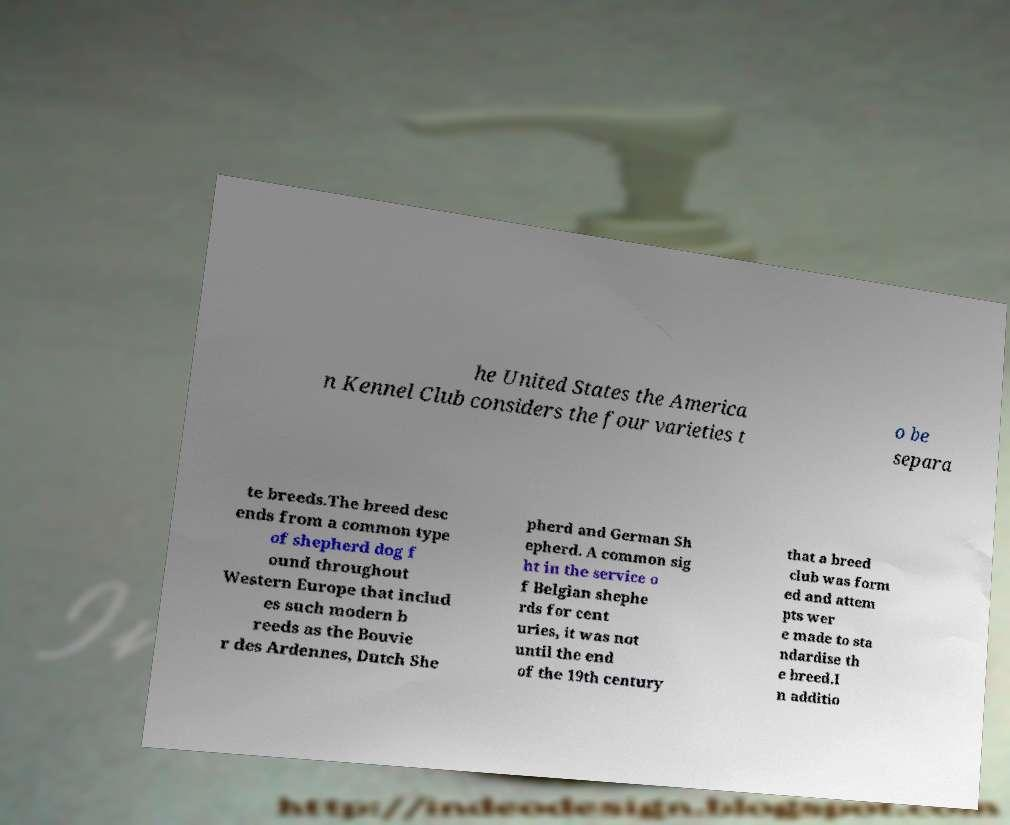What messages or text are displayed in this image? I need them in a readable, typed format. he United States the America n Kennel Club considers the four varieties t o be separa te breeds.The breed desc ends from a common type of shepherd dog f ound throughout Western Europe that includ es such modern b reeds as the Bouvie r des Ardennes, Dutch She pherd and German Sh epherd. A common sig ht in the service o f Belgian shephe rds for cent uries, it was not until the end of the 19th century that a breed club was form ed and attem pts wer e made to sta ndardise th e breed.I n additio 